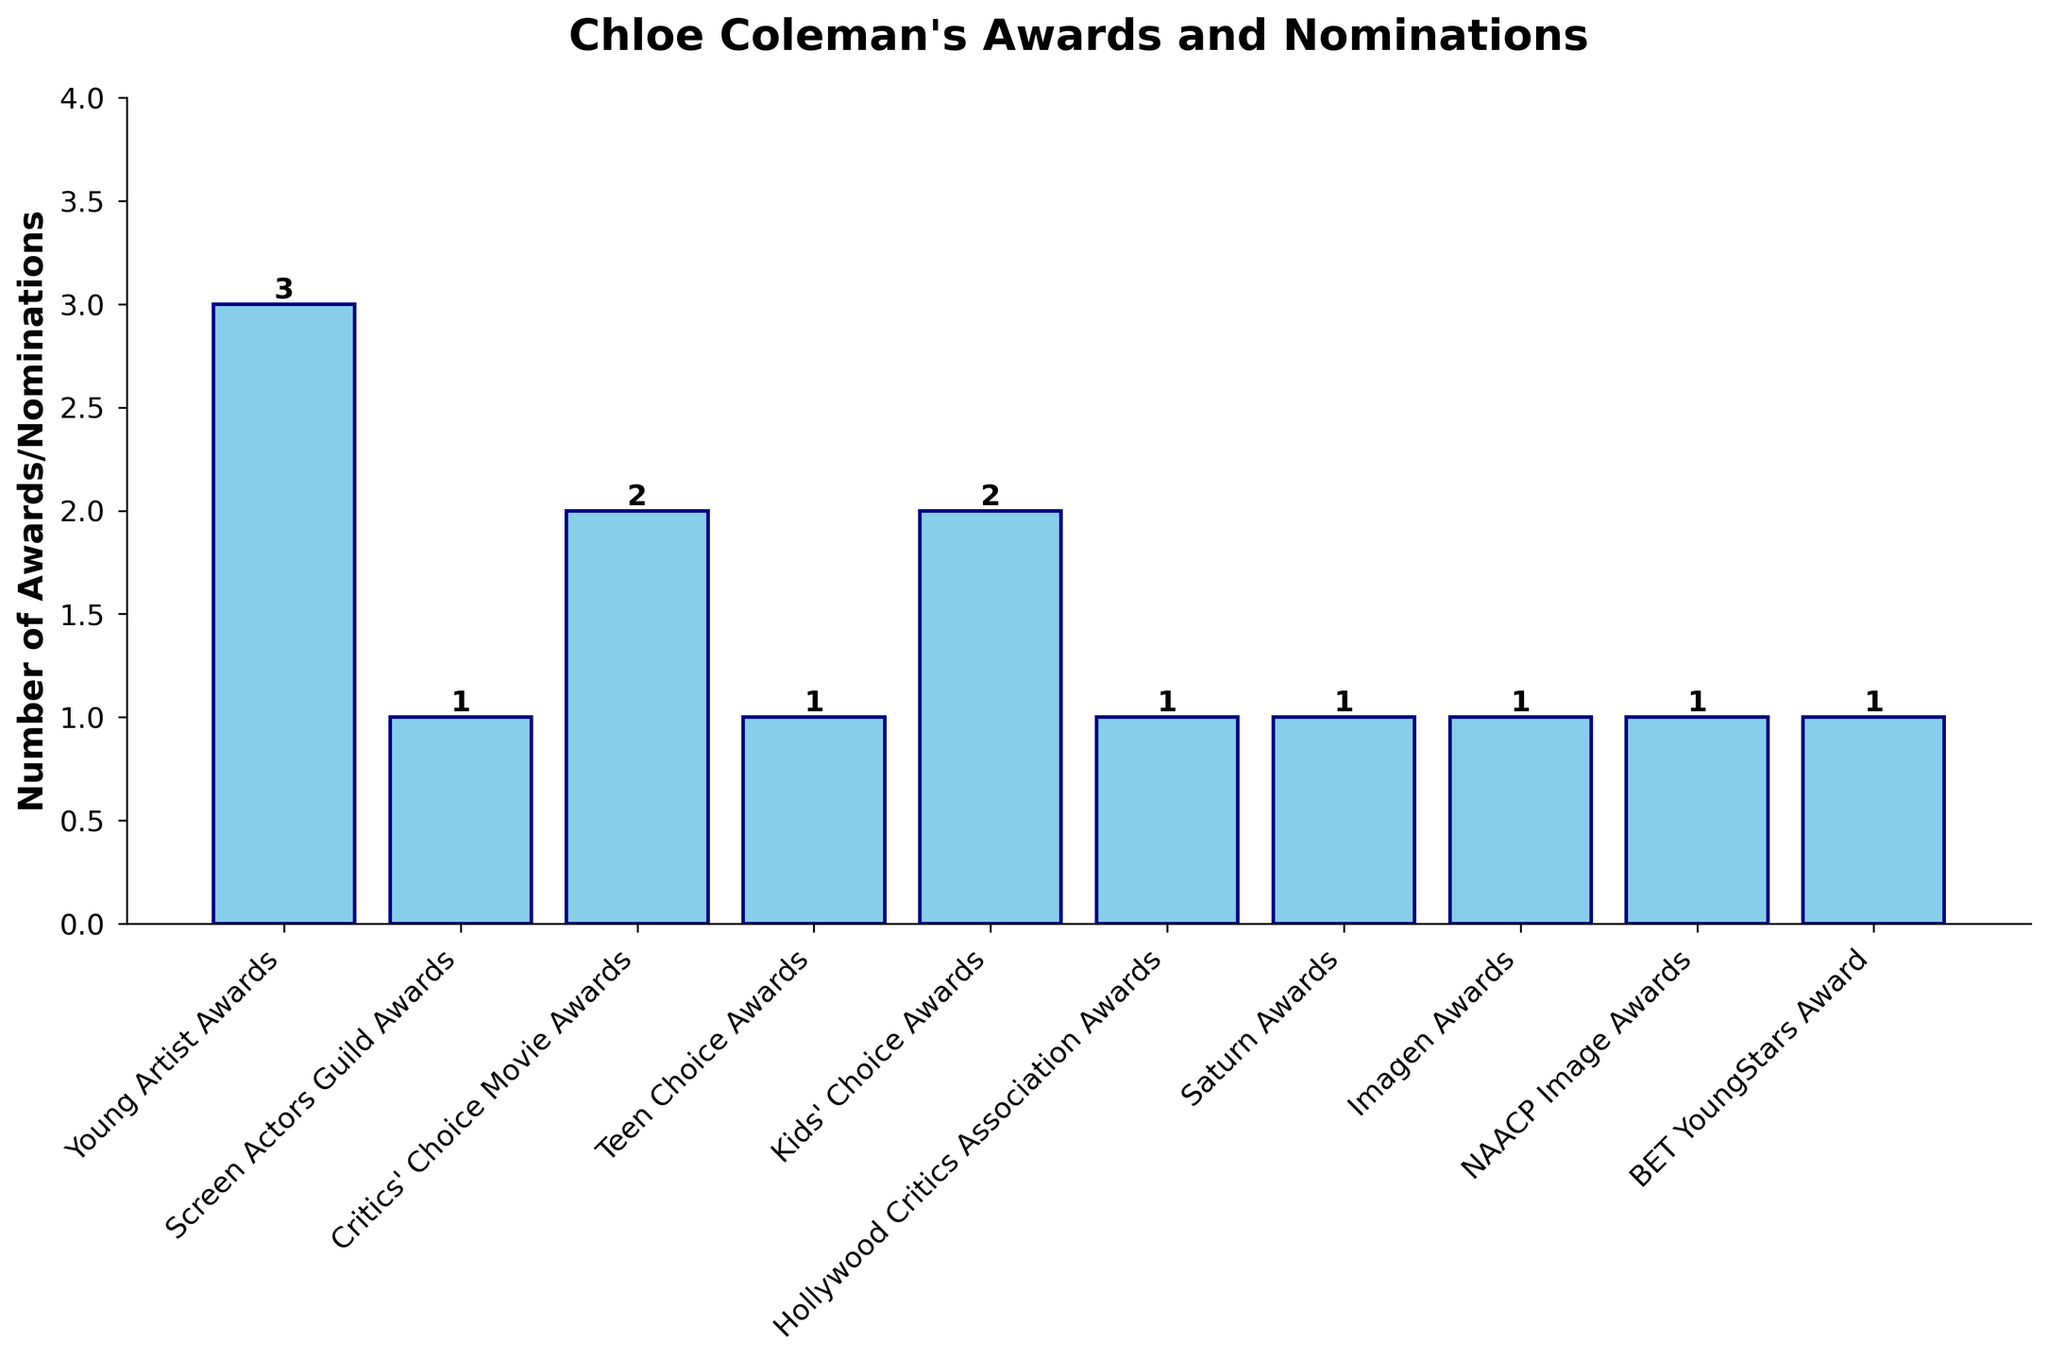Which category has the highest number of awards/nominations? By observing the heights of the bars, we can see that "Young Artist Awards" has the highest bar.
Answer: Young Artist Awards How many total awards/nominations has Chloe Coleman received? To find the total, sum the values of all bars: 3 (Young Artist Awards) + 1 (Screen Actors Guild Awards) + 2 (Critics' Choice Movie Awards) + 1 (Teen Choice Awards) + 2 (Kids' Choice Awards) + 1 (Hollywood Critics Association Awards) + 1 (Saturn Awards) + 1 (Imagen Awards) + 1 (NAACP Image Awards) + 1 (BET YoungStars Award) = 14.
Answer: 14 Which categories have an equal number of awards/nominations? By comparing the heights of the bars, categories with the same height are "Screen Actors Guild Awards," "Teen Choice Awards," "Hollywood Critics Association Awards," "Saturn Awards," "Imagen Awards," "NAACP Image Awards," and "BET YoungStars Award." Each has a height of 1.
Answer: Screen Actors Guild Awards, Teen Choice Awards, Hollywood Critics Association Awards, Saturn Awards, Imagen Awards, NAACP Image Awards, BET YoungStars Award Which category received twice the number of awards/nominations compared to "Screen Actors Guild Awards"? By observing that "Screen Actors Guild Awards" has a value of 1, we need to find a category with twice the value, i.e., 2. "Critics' Choice Movie Awards" and "Kids' Choice Awards" both have a value of 2.
Answer: Critics' Choice Movie Awards, Kids' Choice Awards What is the total number of awards/nominations from the categories with the highest and lowest counts combined? The highest count is 3 (Young Artist Awards), and the lowest count is 1 (several categories). Adding them together: 3 + 1 = 4.
Answer: 4 What is the average number of awards/nominations per category? Sum the total awards/nominations (3+1+2+1+2+1+1+1+1+1 = 14) and divide by the number of categories (10). So, the average is 14 / 10 = 1.4.
Answer: 1.4 Which category is represented by the shortest bar in the bar chart? Several categories have the same shortest bar height of 1, these include "Screen Actors Guild Awards," "Teen Choice Awards," "Hollywood Critics Association Awards," "Saturn Awards," "Imagen Awards," "NAACP Image Awards," and "BET YoungStars Award."
Answer: Screen Actors Guild Awards, Teen Choice Awards, Hollywood Critics Association Awards, Saturn Awards, Imagen Awards, NAACP Image Awards, BET YoungStars Award 